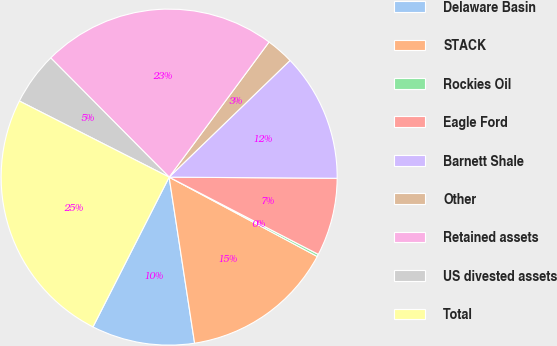<chart> <loc_0><loc_0><loc_500><loc_500><pie_chart><fcel>Delaware Basin<fcel>STACK<fcel>Rockies Oil<fcel>Eagle Ford<fcel>Barnett Shale<fcel>Other<fcel>Retained assets<fcel>US divested assets<fcel>Total<nl><fcel>9.91%<fcel>14.75%<fcel>0.23%<fcel>7.49%<fcel>12.33%<fcel>2.65%<fcel>22.58%<fcel>5.07%<fcel>25.0%<nl></chart> 